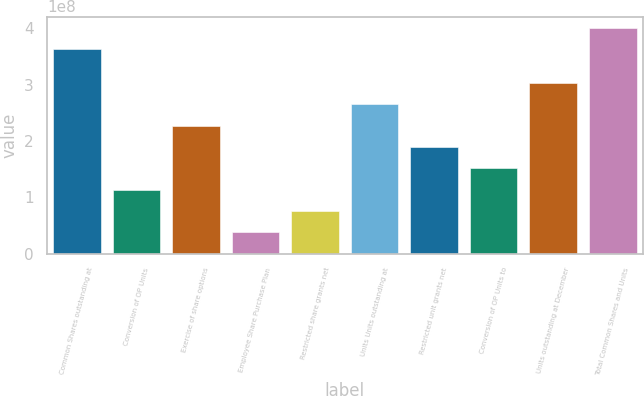<chart> <loc_0><loc_0><loc_500><loc_500><bar_chart><fcel>Common Shares outstanding at<fcel>Conversion of OP Units<fcel>Exercise of share options<fcel>Employee Share Purchase Plan<fcel>Restricted share grants net<fcel>Units Units outstanding at<fcel>Restricted unit grants net<fcel>Conversion of OP Units to<fcel>Units outstanding at December<fcel>Total Common Shares and Units<nl><fcel>3.62855e+08<fcel>1.13755e+08<fcel>2.2751e+08<fcel>3.79183e+07<fcel>7.58365e+07<fcel>2.65428e+08<fcel>1.89591e+08<fcel>1.51673e+08<fcel>3.03346e+08<fcel>4.00774e+08<nl></chart> 